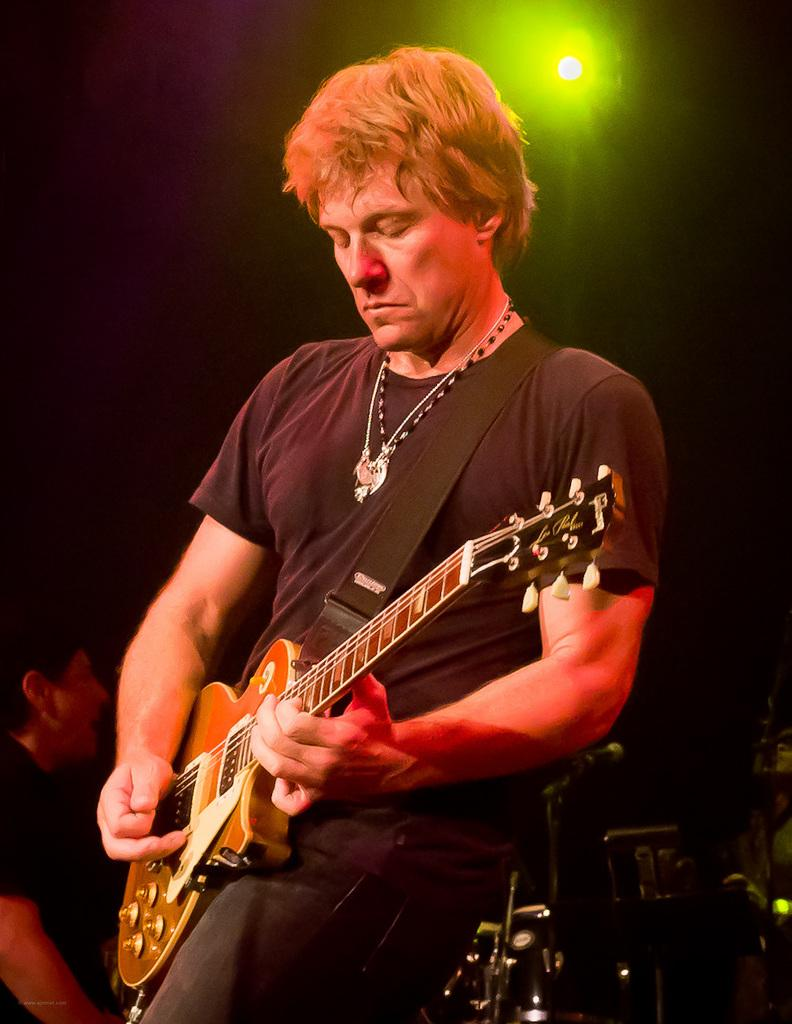What is the man in the image doing? The man is playing a guitar in the image. What is the man wearing in the image? The man is wearing a black color t-shirt in the image. Can you describe any accessories the man is wearing in the image? The man has a chain around his neck in the image. What shape is the peace symbol in the image? There is no peace symbol present in the image. 